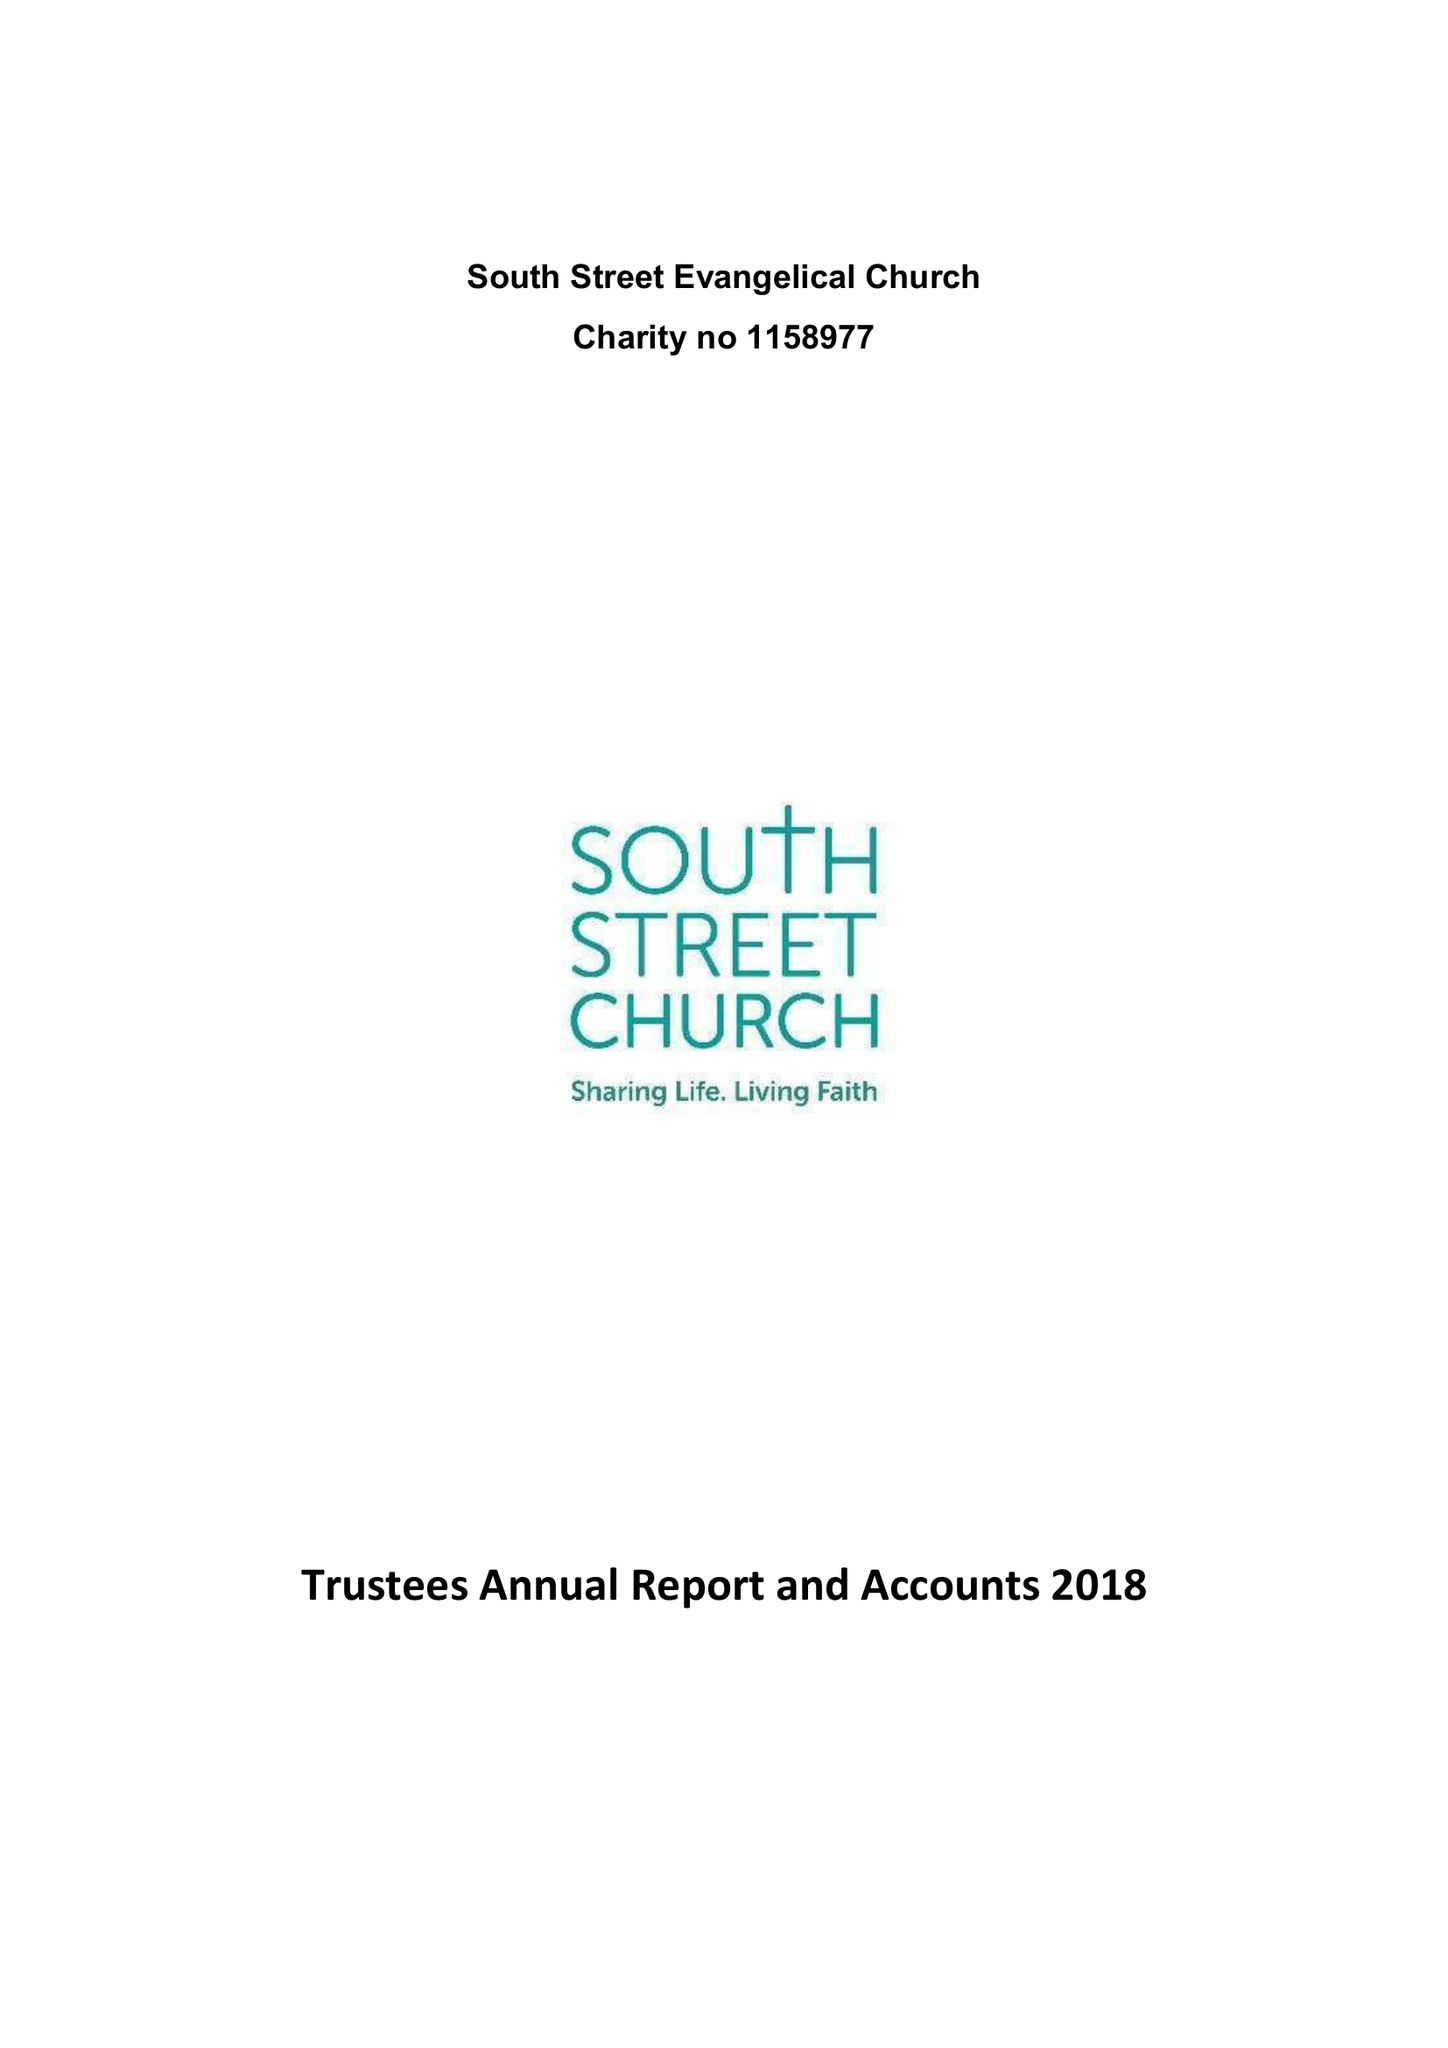What is the value for the income_annually_in_british_pounds?
Answer the question using a single word or phrase. 111078.00 